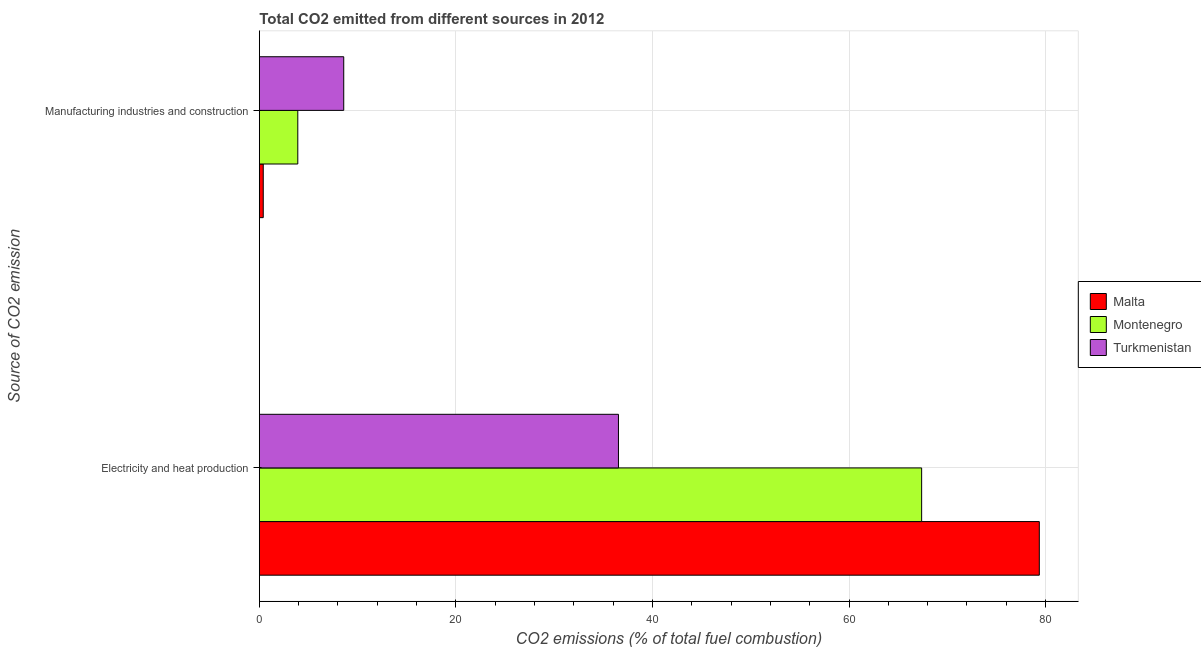How many different coloured bars are there?
Offer a very short reply. 3. How many bars are there on the 1st tick from the bottom?
Keep it short and to the point. 3. What is the label of the 2nd group of bars from the top?
Your answer should be compact. Electricity and heat production. What is the co2 emissions due to electricity and heat production in Malta?
Ensure brevity in your answer.  79.37. Across all countries, what is the maximum co2 emissions due to manufacturing industries?
Your answer should be very brief. 8.59. Across all countries, what is the minimum co2 emissions due to manufacturing industries?
Provide a short and direct response. 0.4. In which country was the co2 emissions due to manufacturing industries maximum?
Provide a short and direct response. Turkmenistan. In which country was the co2 emissions due to electricity and heat production minimum?
Offer a very short reply. Turkmenistan. What is the total co2 emissions due to manufacturing industries in the graph?
Provide a succinct answer. 12.9. What is the difference between the co2 emissions due to manufacturing industries in Malta and that in Turkmenistan?
Your answer should be compact. -8.19. What is the difference between the co2 emissions due to manufacturing industries in Montenegro and the co2 emissions due to electricity and heat production in Turkmenistan?
Your answer should be very brief. -32.63. What is the average co2 emissions due to manufacturing industries per country?
Offer a very short reply. 4.3. What is the difference between the co2 emissions due to electricity and heat production and co2 emissions due to manufacturing industries in Turkmenistan?
Keep it short and to the point. 27.95. In how many countries, is the co2 emissions due to manufacturing industries greater than 60 %?
Offer a terse response. 0. What is the ratio of the co2 emissions due to electricity and heat production in Montenegro to that in Turkmenistan?
Provide a short and direct response. 1.84. Is the co2 emissions due to electricity and heat production in Montenegro less than that in Turkmenistan?
Make the answer very short. No. What does the 2nd bar from the top in Electricity and heat production represents?
Your answer should be compact. Montenegro. What does the 1st bar from the bottom in Electricity and heat production represents?
Offer a very short reply. Malta. Are all the bars in the graph horizontal?
Offer a terse response. Yes. Does the graph contain any zero values?
Ensure brevity in your answer.  No. Does the graph contain grids?
Your answer should be compact. Yes. How many legend labels are there?
Your response must be concise. 3. How are the legend labels stacked?
Offer a very short reply. Vertical. What is the title of the graph?
Your answer should be compact. Total CO2 emitted from different sources in 2012. What is the label or title of the X-axis?
Offer a terse response. CO2 emissions (% of total fuel combustion). What is the label or title of the Y-axis?
Keep it short and to the point. Source of CO2 emission. What is the CO2 emissions (% of total fuel combustion) in Malta in Electricity and heat production?
Your answer should be very brief. 79.37. What is the CO2 emissions (% of total fuel combustion) in Montenegro in Electricity and heat production?
Your response must be concise. 67.39. What is the CO2 emissions (% of total fuel combustion) of Turkmenistan in Electricity and heat production?
Make the answer very short. 36.54. What is the CO2 emissions (% of total fuel combustion) in Malta in Manufacturing industries and construction?
Your answer should be compact. 0.4. What is the CO2 emissions (% of total fuel combustion) in Montenegro in Manufacturing industries and construction?
Your response must be concise. 3.91. What is the CO2 emissions (% of total fuel combustion) of Turkmenistan in Manufacturing industries and construction?
Your answer should be very brief. 8.59. Across all Source of CO2 emission, what is the maximum CO2 emissions (% of total fuel combustion) in Malta?
Your answer should be compact. 79.37. Across all Source of CO2 emission, what is the maximum CO2 emissions (% of total fuel combustion) in Montenegro?
Keep it short and to the point. 67.39. Across all Source of CO2 emission, what is the maximum CO2 emissions (% of total fuel combustion) of Turkmenistan?
Your answer should be very brief. 36.54. Across all Source of CO2 emission, what is the minimum CO2 emissions (% of total fuel combustion) of Malta?
Give a very brief answer. 0.4. Across all Source of CO2 emission, what is the minimum CO2 emissions (% of total fuel combustion) of Montenegro?
Your answer should be very brief. 3.91. Across all Source of CO2 emission, what is the minimum CO2 emissions (% of total fuel combustion) of Turkmenistan?
Your answer should be compact. 8.59. What is the total CO2 emissions (% of total fuel combustion) in Malta in the graph?
Your response must be concise. 79.76. What is the total CO2 emissions (% of total fuel combustion) in Montenegro in the graph?
Your answer should be compact. 71.3. What is the total CO2 emissions (% of total fuel combustion) of Turkmenistan in the graph?
Your answer should be very brief. 45.13. What is the difference between the CO2 emissions (% of total fuel combustion) in Malta in Electricity and heat production and that in Manufacturing industries and construction?
Offer a terse response. 78.97. What is the difference between the CO2 emissions (% of total fuel combustion) in Montenegro in Electricity and heat production and that in Manufacturing industries and construction?
Your answer should be compact. 63.48. What is the difference between the CO2 emissions (% of total fuel combustion) in Turkmenistan in Electricity and heat production and that in Manufacturing industries and construction?
Provide a short and direct response. 27.95. What is the difference between the CO2 emissions (% of total fuel combustion) of Malta in Electricity and heat production and the CO2 emissions (% of total fuel combustion) of Montenegro in Manufacturing industries and construction?
Provide a short and direct response. 75.45. What is the difference between the CO2 emissions (% of total fuel combustion) in Malta in Electricity and heat production and the CO2 emissions (% of total fuel combustion) in Turkmenistan in Manufacturing industries and construction?
Provide a succinct answer. 70.78. What is the difference between the CO2 emissions (% of total fuel combustion) in Montenegro in Electricity and heat production and the CO2 emissions (% of total fuel combustion) in Turkmenistan in Manufacturing industries and construction?
Your answer should be compact. 58.8. What is the average CO2 emissions (% of total fuel combustion) in Malta per Source of CO2 emission?
Offer a terse response. 39.88. What is the average CO2 emissions (% of total fuel combustion) in Montenegro per Source of CO2 emission?
Offer a terse response. 35.65. What is the average CO2 emissions (% of total fuel combustion) in Turkmenistan per Source of CO2 emission?
Provide a succinct answer. 22.56. What is the difference between the CO2 emissions (% of total fuel combustion) in Malta and CO2 emissions (% of total fuel combustion) in Montenegro in Electricity and heat production?
Give a very brief answer. 11.97. What is the difference between the CO2 emissions (% of total fuel combustion) in Malta and CO2 emissions (% of total fuel combustion) in Turkmenistan in Electricity and heat production?
Give a very brief answer. 42.82. What is the difference between the CO2 emissions (% of total fuel combustion) in Montenegro and CO2 emissions (% of total fuel combustion) in Turkmenistan in Electricity and heat production?
Keep it short and to the point. 30.85. What is the difference between the CO2 emissions (% of total fuel combustion) of Malta and CO2 emissions (% of total fuel combustion) of Montenegro in Manufacturing industries and construction?
Your response must be concise. -3.52. What is the difference between the CO2 emissions (% of total fuel combustion) of Malta and CO2 emissions (% of total fuel combustion) of Turkmenistan in Manufacturing industries and construction?
Ensure brevity in your answer.  -8.19. What is the difference between the CO2 emissions (% of total fuel combustion) in Montenegro and CO2 emissions (% of total fuel combustion) in Turkmenistan in Manufacturing industries and construction?
Your response must be concise. -4.67. What is the ratio of the CO2 emissions (% of total fuel combustion) in Montenegro in Electricity and heat production to that in Manufacturing industries and construction?
Your answer should be very brief. 17.22. What is the ratio of the CO2 emissions (% of total fuel combustion) of Turkmenistan in Electricity and heat production to that in Manufacturing industries and construction?
Provide a succinct answer. 4.26. What is the difference between the highest and the second highest CO2 emissions (% of total fuel combustion) of Malta?
Offer a very short reply. 78.97. What is the difference between the highest and the second highest CO2 emissions (% of total fuel combustion) in Montenegro?
Offer a terse response. 63.48. What is the difference between the highest and the second highest CO2 emissions (% of total fuel combustion) of Turkmenistan?
Your response must be concise. 27.95. What is the difference between the highest and the lowest CO2 emissions (% of total fuel combustion) in Malta?
Ensure brevity in your answer.  78.97. What is the difference between the highest and the lowest CO2 emissions (% of total fuel combustion) in Montenegro?
Keep it short and to the point. 63.48. What is the difference between the highest and the lowest CO2 emissions (% of total fuel combustion) in Turkmenistan?
Provide a short and direct response. 27.95. 